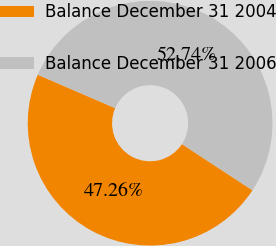Convert chart. <chart><loc_0><loc_0><loc_500><loc_500><pie_chart><fcel>Balance December 31 2004<fcel>Balance December 31 2006<nl><fcel>47.26%<fcel>52.74%<nl></chart> 